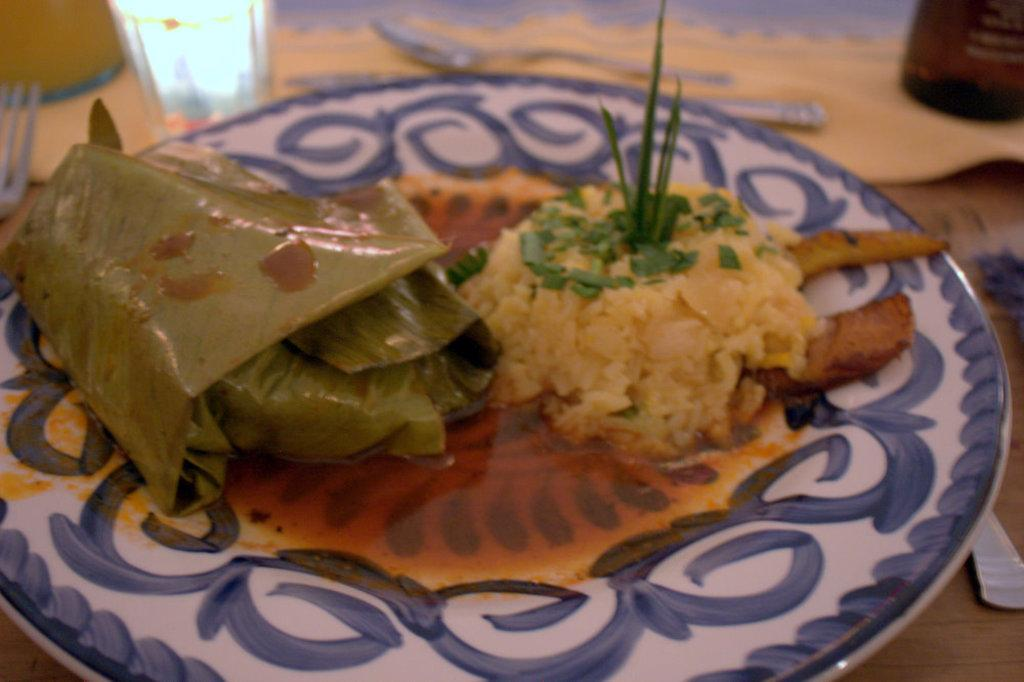What object is present in the image that typically holds food? There is a plate in the image that typically holds food. What is on the plate in the image? The plate contains food. What is located behind the plate in the image? There is a glass behind the plate. What utensils are present around the plate in the image? There are spoons around the plate. What type of theory is being discussed by the scarecrow in the image? There is no scarecrow present in the image, so it is not possible to discuss any theories with it. 